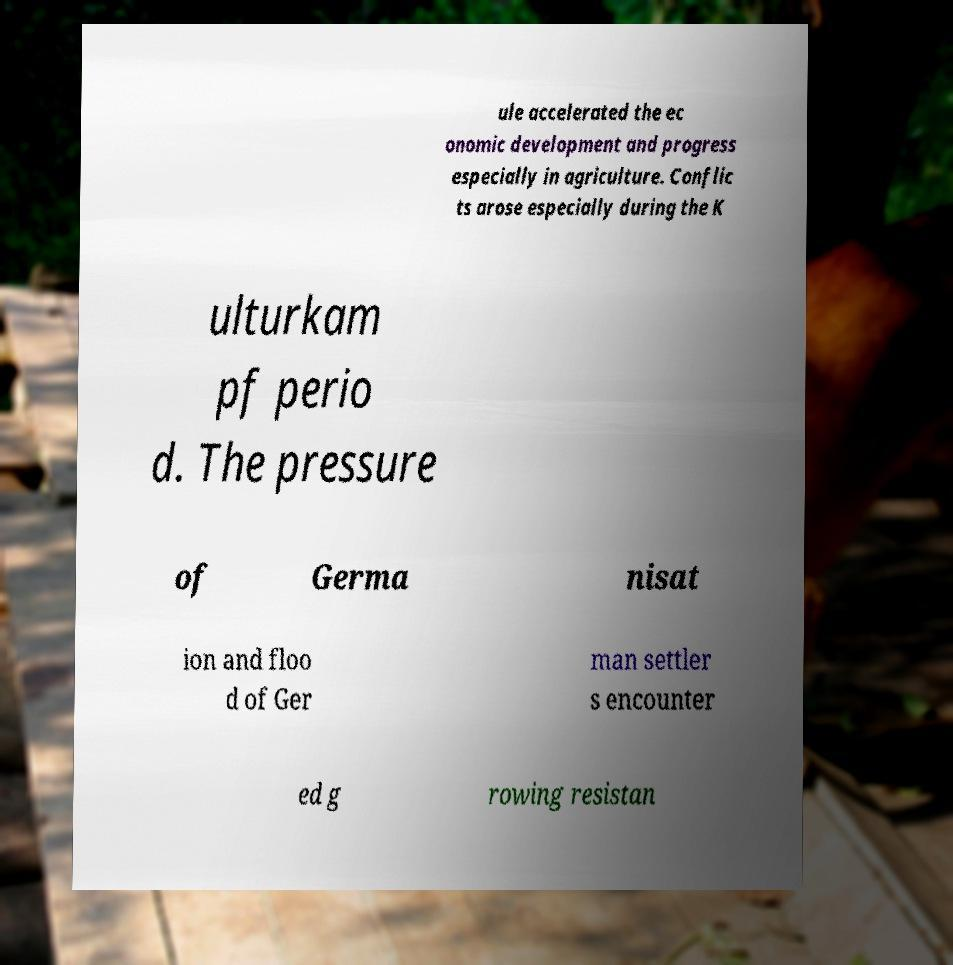Could you assist in decoding the text presented in this image and type it out clearly? ule accelerated the ec onomic development and progress especially in agriculture. Conflic ts arose especially during the K ulturkam pf perio d. The pressure of Germa nisat ion and floo d of Ger man settler s encounter ed g rowing resistan 